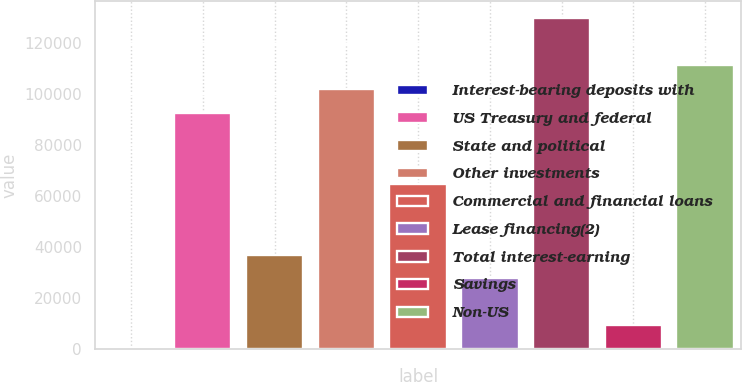Convert chart. <chart><loc_0><loc_0><loc_500><loc_500><bar_chart><fcel>Interest-bearing deposits with<fcel>US Treasury and federal<fcel>State and political<fcel>Other investments<fcel>Commercial and financial loans<fcel>Lease financing(2)<fcel>Total interest-earning<fcel>Savings<fcel>Non-US<nl><fcel>40<fcel>92665<fcel>37090<fcel>101928<fcel>64877.5<fcel>27827.5<fcel>129715<fcel>9302.5<fcel>111190<nl></chart> 